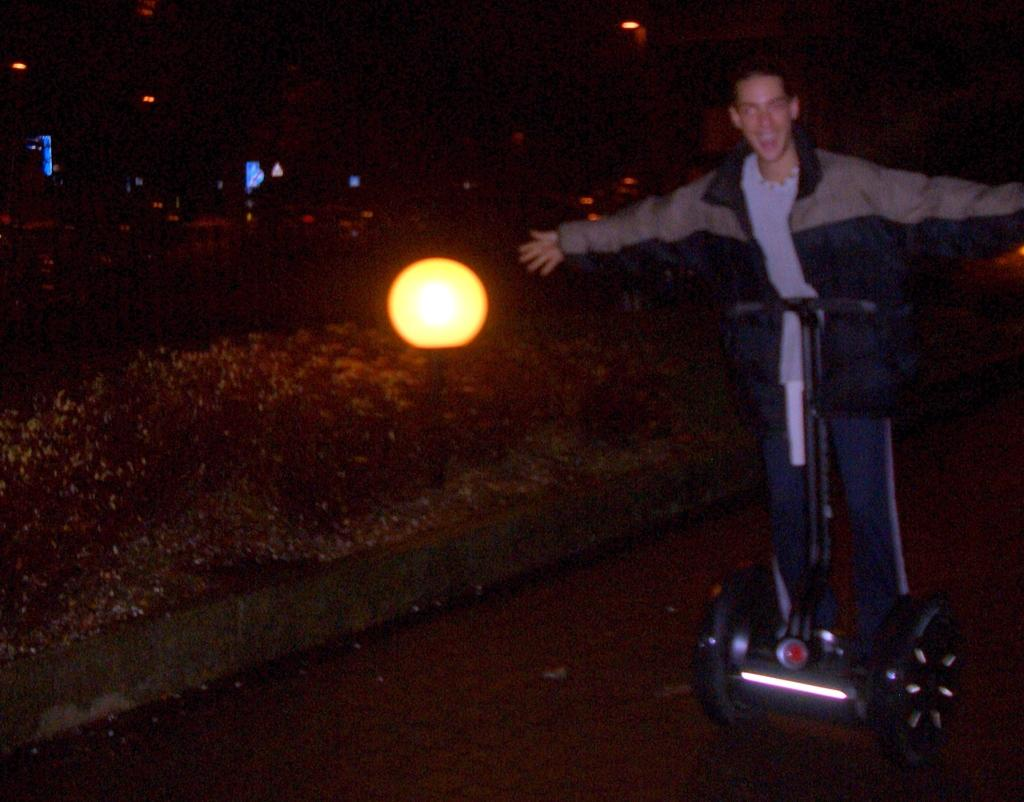What is the person in the image doing? The person is standing on a segway in the image. How does the person appear to feel in the image? The person has a smile on their face, indicating they are happy or enjoying themselves. What is located beside the person in the image? There is a street light beside the person in the image. What can be observed about the lighting conditions in the image? The background of the image is dark, suggesting it might be nighttime or in a poorly lit area. What type of class is the person attending in the image? There is no indication of a class or any educational setting in the image; the person is standing on a segway. 